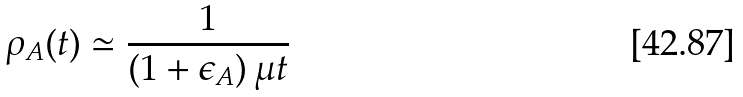Convert formula to latex. <formula><loc_0><loc_0><loc_500><loc_500>\rho _ { A } ( t ) \simeq \frac { 1 } { ( 1 + \epsilon _ { A } ) \, \mu t }</formula> 